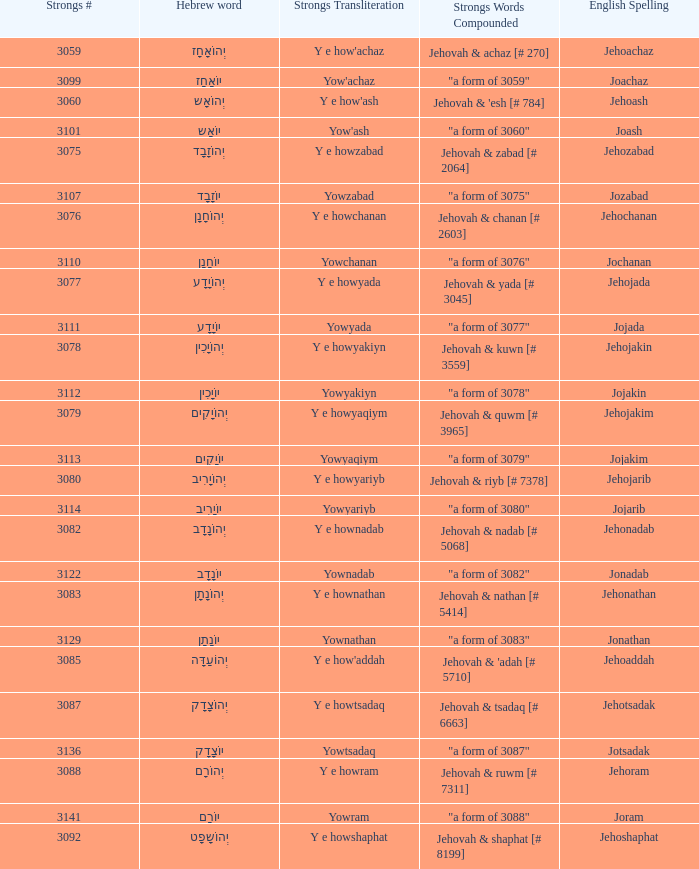How many strongs transliteration of the english spelling of the work jehojakin? 1.0. 